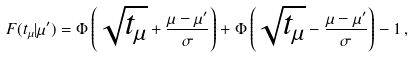Convert formula to latex. <formula><loc_0><loc_0><loc_500><loc_500>F ( t _ { \mu } | \mu ^ { \prime } ) = \Phi \left ( \sqrt { t _ { \mu } } + \frac { \mu - \mu ^ { \prime } } { \sigma } \right ) + \Phi \left ( \sqrt { t _ { \mu } } - \frac { \mu - \mu ^ { \prime } } { \sigma } \right ) - 1 \, ,</formula> 